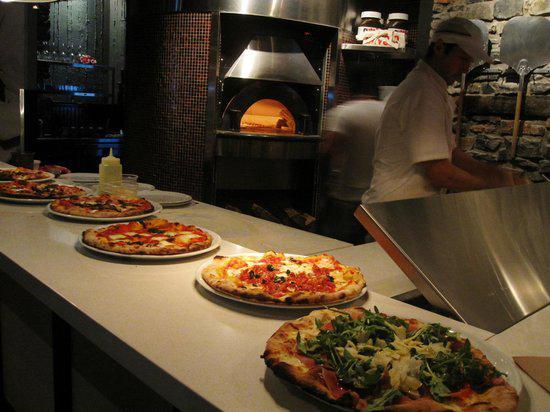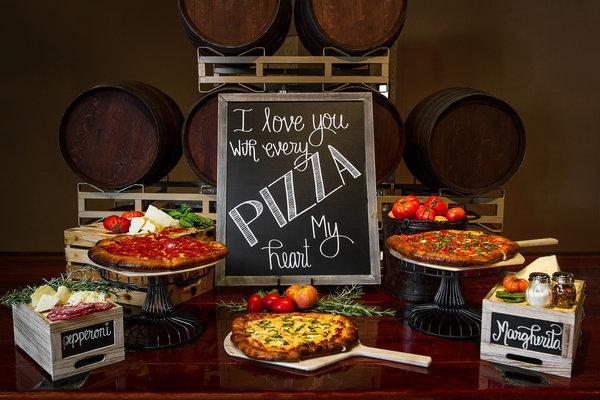The first image is the image on the left, the second image is the image on the right. Considering the images on both sides, is "A sign on the chalkboard is announcing the food on the table in one of the images." valid? Answer yes or no. Yes. The first image is the image on the left, the second image is the image on the right. Given the left and right images, does the statement "In the image on the right, some pizzas are raised on stands." hold true? Answer yes or no. Yes. 